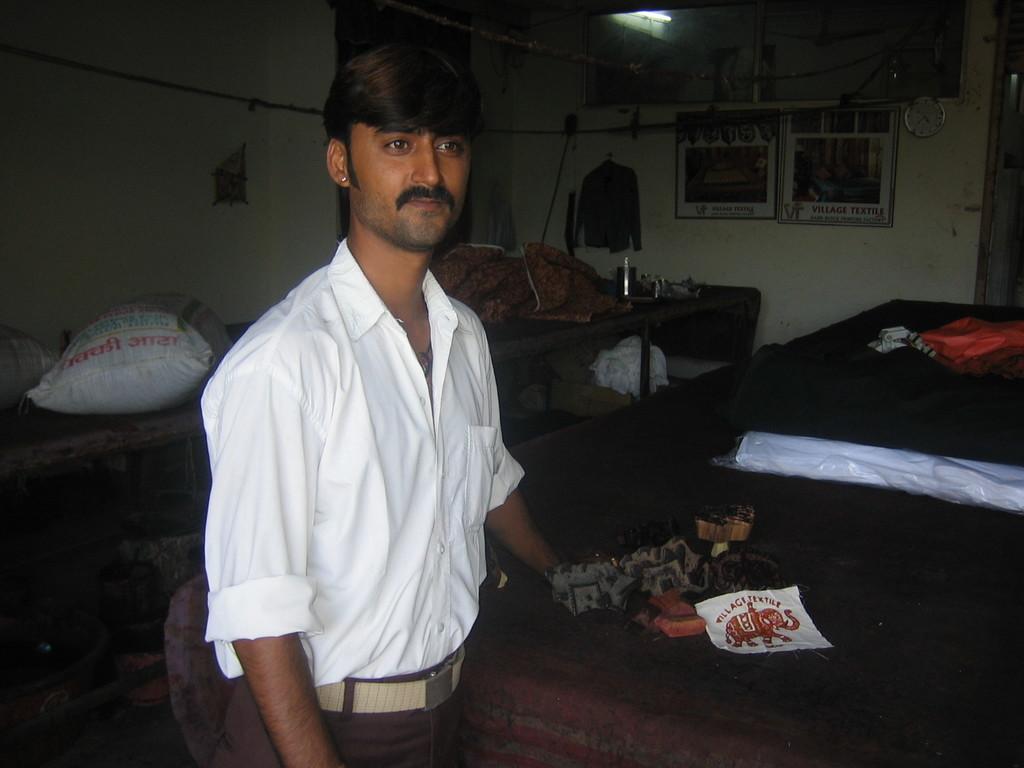How would you summarize this image in a sentence or two? In the center of the image there is a person standing on the floor. In the background we can see bed, clock, posters, shirt, table, tube light and wall. 